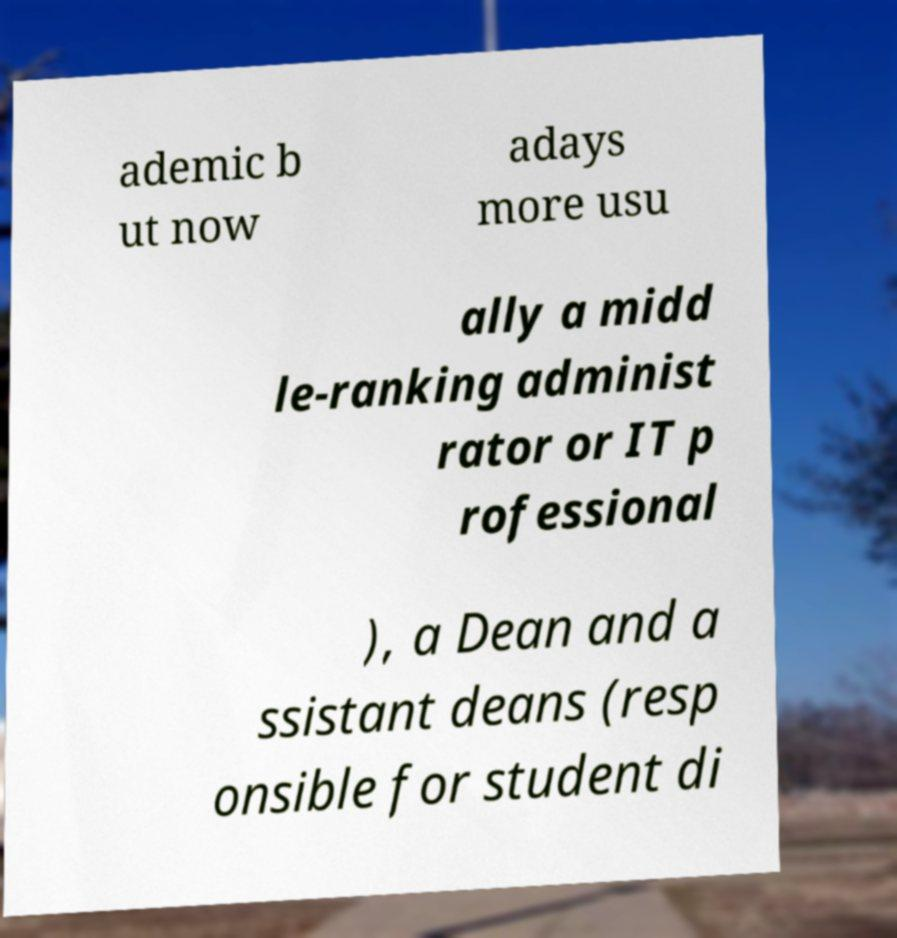Can you accurately transcribe the text from the provided image for me? ademic b ut now adays more usu ally a midd le-ranking administ rator or IT p rofessional ), a Dean and a ssistant deans (resp onsible for student di 